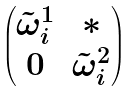<formula> <loc_0><loc_0><loc_500><loc_500>\begin{pmatrix} \tilde { \omega } _ { i } ^ { 1 } & * \\ 0 & \tilde { \omega } _ { i } ^ { 2 } \end{pmatrix}</formula> 